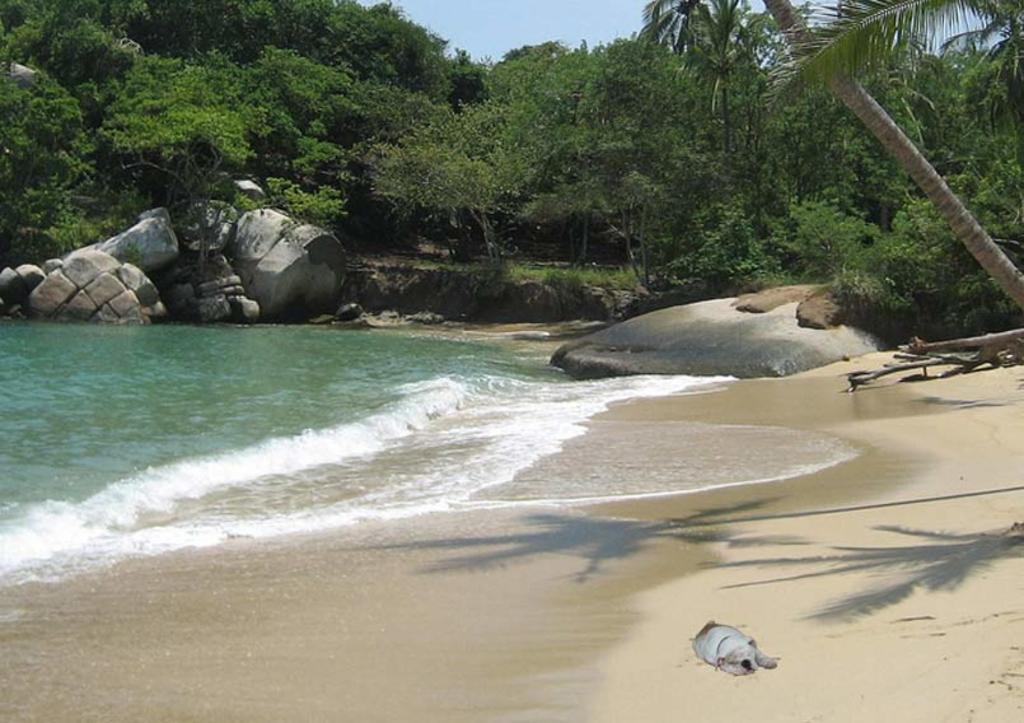What type of natural environment is depicted in the image? The image features trees, rocks, sand, and water, which suggests a beach or coastal setting. Can you describe the ground in the image? The ground in the image consists of sand. What is visible in the background of the image? The sky is visible in the image. What is the water in the image doing? The water is visible in the image, but its motion or behavior is not specified. What type of rail can be seen in the image? There is no rail present in the image. 